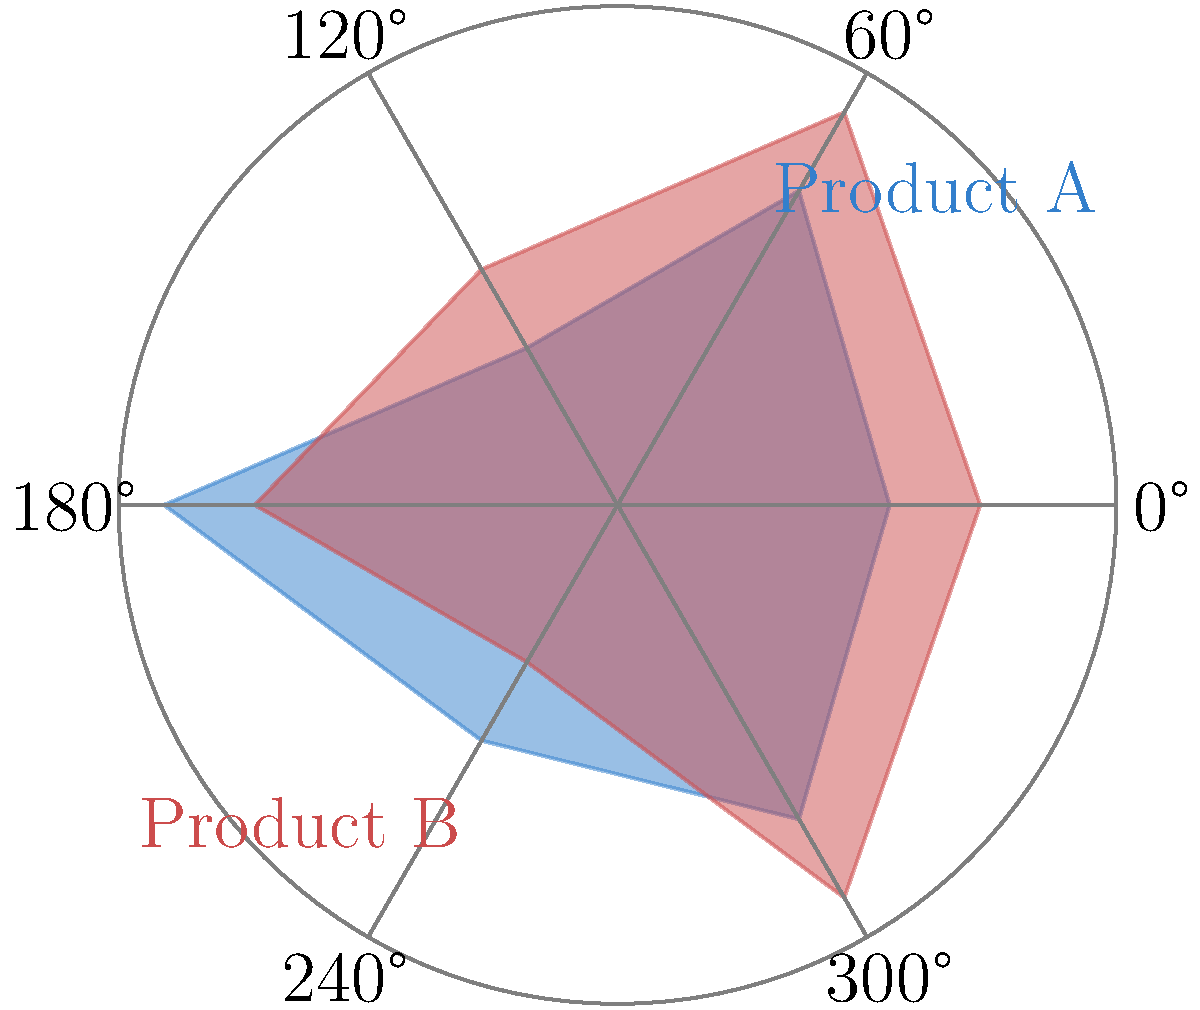As a tech startup founder who pivoted during the pandemic, you're analyzing market share changes for two product categories. The polar coordinate graph shows the market share distribution across six regions (represented by angles) for Product A (blue) and Product B (red) before and after your strategy pivot. If the total market size remained constant, what was the percentage increase in Product B's overall market share? To calculate the percentage increase in Product B's overall market share, we need to follow these steps:

1. Calculate the total area for each product before the pivot:
   Product A: $\sum_{i=1}^{6} r1_i = 3 + 4 + 2 + 5 + 3 + 4 = 21$
   Product B: $\sum_{i=1}^{6} r2_i = 4 + 5 + 3 + 4 + 2 + 5 = 23$

2. Calculate the total market size:
   Total = Product A + Product B = 21 + 23 = 44

3. Calculate the initial market shares:
   Product A: $\frac{21}{44} \times 100\% = 47.73\%$
   Product B: $\frac{23}{44} \times 100\% = 52.27\%$

4. Calculate the new total for Product B after the pivot:
   New Product B: $\sum_{i=1}^{6} r2_i = 4 + 5 + 3 + 4 + 2 + 5 = 23$
   (Note: The values remain the same as the question states the total market size remained constant)

5. Calculate the new market share for Product B:
   New Product B share: $\frac{23}{44} \times 100\% = 52.27\%$

6. Calculate the percentage increase:
   Percentage increase = $\frac{\text{New share} - \text{Original share}}{\text{Original share}} \times 100\%$
   $= \frac{52.27\% - 52.27\%}{52.27\%} \times 100\% = 0\%$
Answer: 0% 